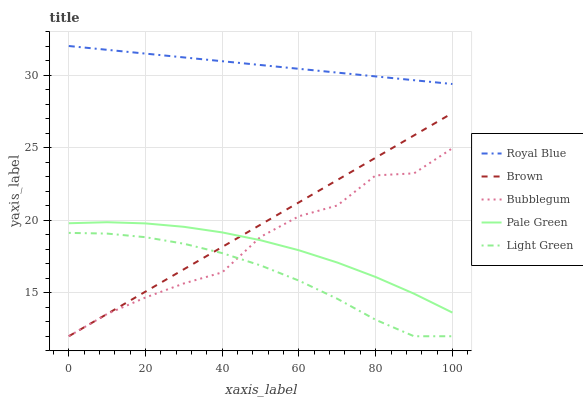Does Pale Green have the minimum area under the curve?
Answer yes or no. No. Does Pale Green have the maximum area under the curve?
Answer yes or no. No. Is Pale Green the smoothest?
Answer yes or no. No. Is Pale Green the roughest?
Answer yes or no. No. Does Pale Green have the lowest value?
Answer yes or no. No. Does Pale Green have the highest value?
Answer yes or no. No. Is Light Green less than Pale Green?
Answer yes or no. Yes. Is Pale Green greater than Light Green?
Answer yes or no. Yes. Does Light Green intersect Pale Green?
Answer yes or no. No. 